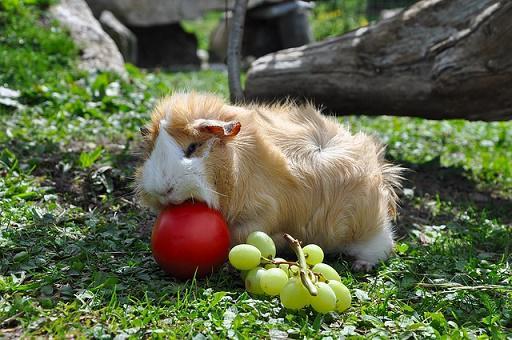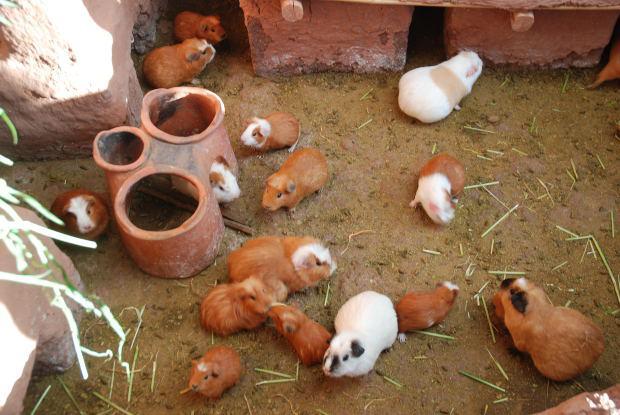The first image is the image on the left, the second image is the image on the right. Assess this claim about the two images: "In at least one of the pictures, at least one guinea pig is eating". Correct or not? Answer yes or no. Yes. The first image is the image on the left, the second image is the image on the right. Analyze the images presented: Is the assertion "There is exactly one animal in the image on the left" valid? Answer yes or no. Yes. The first image is the image on the left, the second image is the image on the right. Examine the images to the left and right. Is the description "One image shows a little animal with a white nose in a grassy area near some fruit it has been given to eat." accurate? Answer yes or no. Yes. The first image is the image on the left, the second image is the image on the right. Assess this claim about the two images: "One of the images shows exactly two guinea pigs.". Correct or not? Answer yes or no. No. 